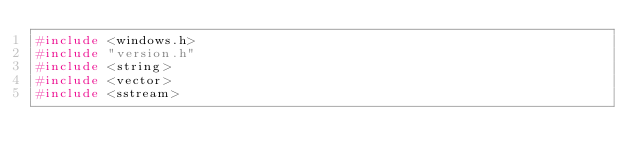<code> <loc_0><loc_0><loc_500><loc_500><_C_>#include <windows.h>
#include "version.h"
#include <string>
#include <vector>
#include <sstream></code> 